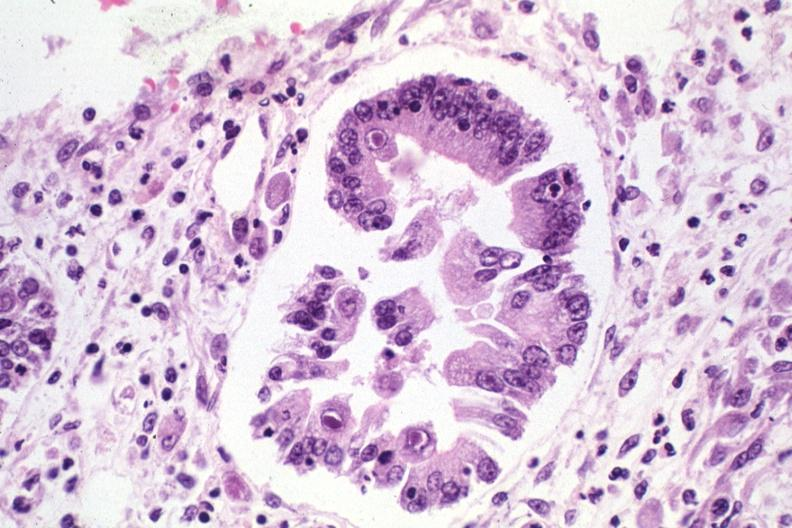what is present?
Answer the question using a single word or phrase. Gastrointestinal 